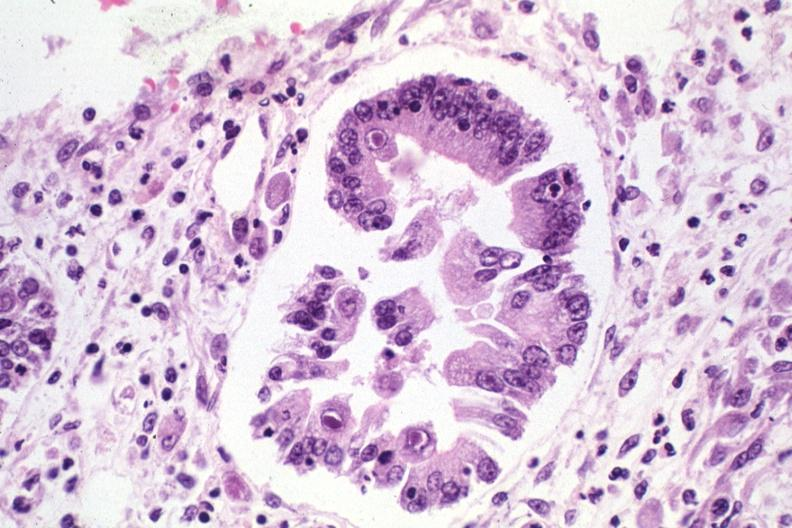what is present?
Answer the question using a single word or phrase. Gastrointestinal 